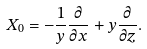Convert formula to latex. <formula><loc_0><loc_0><loc_500><loc_500>X _ { 0 } = - \frac { 1 } { y } \frac { \partial } { \partial x } + y \frac { \partial } { \partial z } .</formula> 